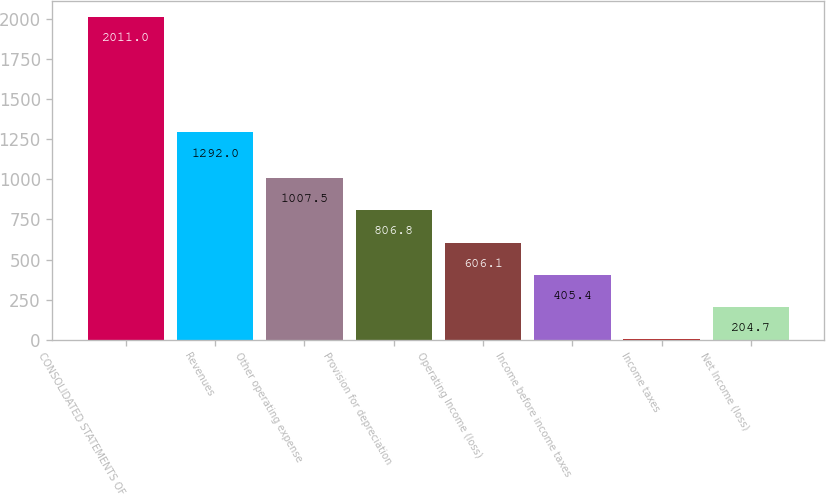<chart> <loc_0><loc_0><loc_500><loc_500><bar_chart><fcel>CONSOLIDATED STATEMENTS OF<fcel>Revenues<fcel>Other operating expense<fcel>Provision for depreciation<fcel>Operating Income (loss)<fcel>Income before income taxes<fcel>Income taxes<fcel>Net Income (loss)<nl><fcel>2011<fcel>1292<fcel>1007.5<fcel>806.8<fcel>606.1<fcel>405.4<fcel>4<fcel>204.7<nl></chart> 